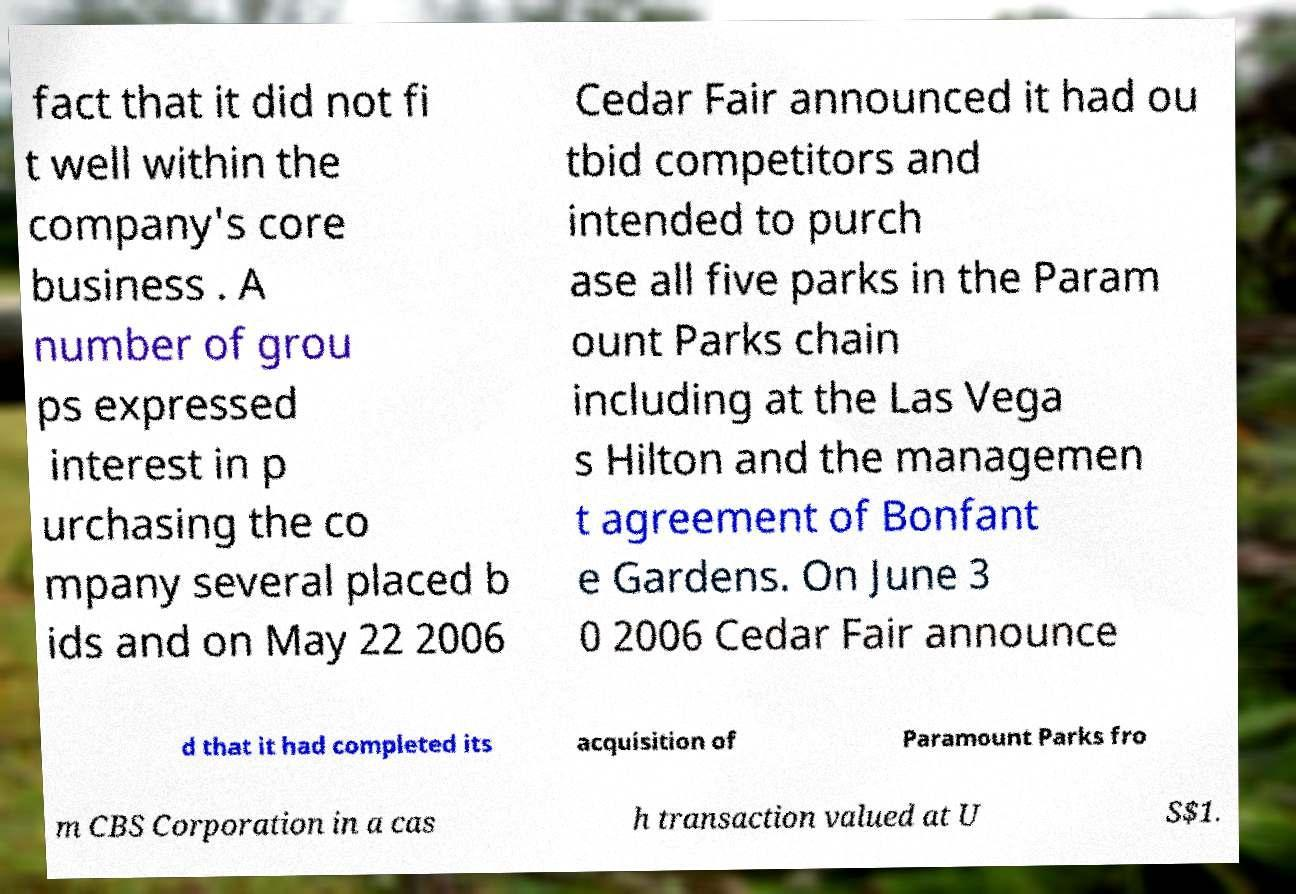Can you read and provide the text displayed in the image?This photo seems to have some interesting text. Can you extract and type it out for me? fact that it did not fi t well within the company's core business . A number of grou ps expressed interest in p urchasing the co mpany several placed b ids and on May 22 2006 Cedar Fair announced it had ou tbid competitors and intended to purch ase all five parks in the Param ount Parks chain including at the Las Vega s Hilton and the managemen t agreement of Bonfant e Gardens. On June 3 0 2006 Cedar Fair announce d that it had completed its acquisition of Paramount Parks fro m CBS Corporation in a cas h transaction valued at U S$1. 